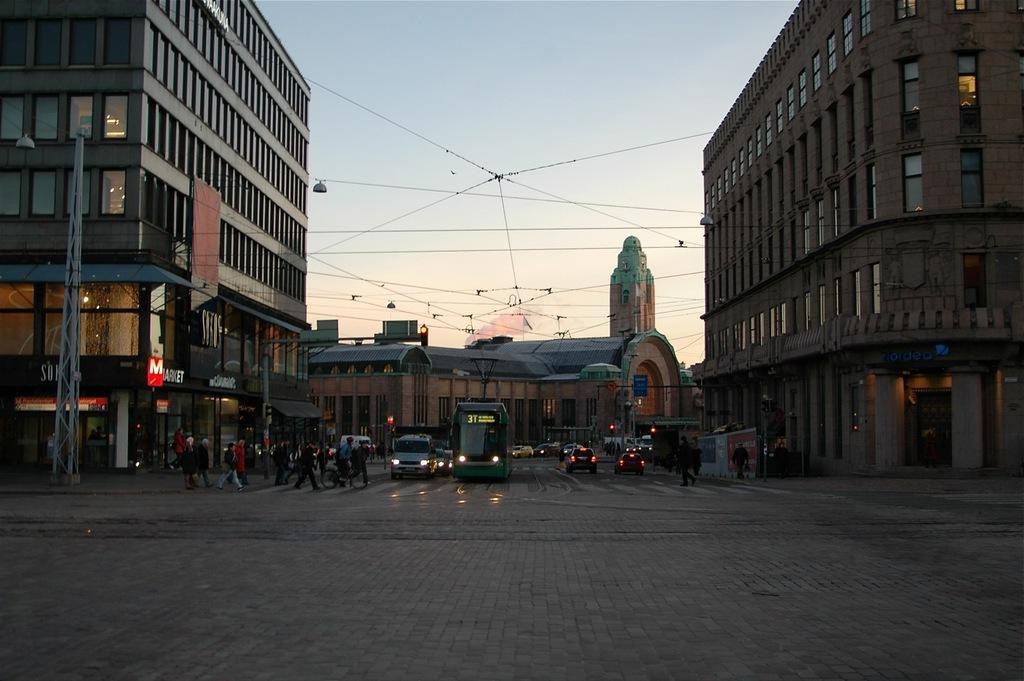Could you give a brief overview of what you see in this image? In this picture I can see vehicles on the road, there are group of people standing, there are buildings, cables, boards, and in the background there is sky. 